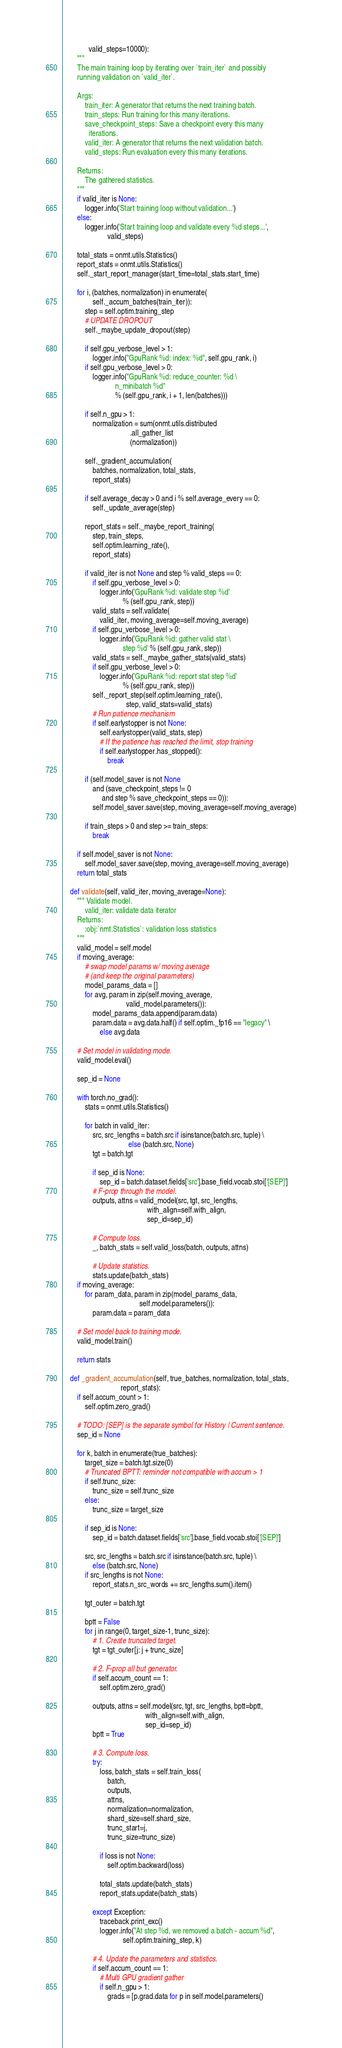<code> <loc_0><loc_0><loc_500><loc_500><_Python_>              valid_steps=10000):
        """
        The main training loop by iterating over `train_iter` and possibly
        running validation on `valid_iter`.

        Args:
            train_iter: A generator that returns the next training batch.
            train_steps: Run training for this many iterations.
            save_checkpoint_steps: Save a checkpoint every this many
              iterations.
            valid_iter: A generator that returns the next validation batch.
            valid_steps: Run evaluation every this many iterations.

        Returns:
            The gathered statistics.
        """
        if valid_iter is None:
            logger.info('Start training loop without validation...')
        else:
            logger.info('Start training loop and validate every %d steps...',
                        valid_steps)

        total_stats = onmt.utils.Statistics()
        report_stats = onmt.utils.Statistics()
        self._start_report_manager(start_time=total_stats.start_time)

        for i, (batches, normalization) in enumerate(
                self._accum_batches(train_iter)):
            step = self.optim.training_step
            # UPDATE DROPOUT
            self._maybe_update_dropout(step)

            if self.gpu_verbose_level > 1:
                logger.info("GpuRank %d: index: %d", self.gpu_rank, i)
            if self.gpu_verbose_level > 0:
                logger.info("GpuRank %d: reduce_counter: %d \
                            n_minibatch %d"
                            % (self.gpu_rank, i + 1, len(batches)))

            if self.n_gpu > 1:
                normalization = sum(onmt.utils.distributed
                                    .all_gather_list
                                    (normalization))

            self._gradient_accumulation(
                batches, normalization, total_stats,
                report_stats)

            if self.average_decay > 0 and i % self.average_every == 0:
                self._update_average(step)

            report_stats = self._maybe_report_training(
                step, train_steps,
                self.optim.learning_rate(),
                report_stats)

            if valid_iter is not None and step % valid_steps == 0:
                if self.gpu_verbose_level > 0:
                    logger.info('GpuRank %d: validate step %d'
                                % (self.gpu_rank, step))
                valid_stats = self.validate(
                    valid_iter, moving_average=self.moving_average)
                if self.gpu_verbose_level > 0:
                    logger.info('GpuRank %d: gather valid stat \
                                step %d' % (self.gpu_rank, step))
                valid_stats = self._maybe_gather_stats(valid_stats)
                if self.gpu_verbose_level > 0:
                    logger.info('GpuRank %d: report stat step %d'
                                % (self.gpu_rank, step))
                self._report_step(self.optim.learning_rate(),
                                  step, valid_stats=valid_stats)
                # Run patience mechanism
                if self.earlystopper is not None:
                    self.earlystopper(valid_stats, step)
                    # If the patience has reached the limit, stop training
                    if self.earlystopper.has_stopped():
                        break

            if (self.model_saver is not None
                and (save_checkpoint_steps != 0
                     and step % save_checkpoint_steps == 0)):
                self.model_saver.save(step, moving_average=self.moving_average)

            if train_steps > 0 and step >= train_steps:
                break

        if self.model_saver is not None:
            self.model_saver.save(step, moving_average=self.moving_average)
        return total_stats

    def validate(self, valid_iter, moving_average=None):
        """ Validate model.
            valid_iter: validate data iterator
        Returns:
            :obj:`nmt.Statistics`: validation loss statistics
        """
        valid_model = self.model
        if moving_average:
            # swap model params w/ moving average
            # (and keep the original parameters)
            model_params_data = []
            for avg, param in zip(self.moving_average,
                                  valid_model.parameters()):
                model_params_data.append(param.data)
                param.data = avg.data.half() if self.optim._fp16 == "legacy" \
                    else avg.data

        # Set model in validating mode.
        valid_model.eval()

        sep_id = None

        with torch.no_grad():
            stats = onmt.utils.Statistics()

            for batch in valid_iter:
                src, src_lengths = batch.src if isinstance(batch.src, tuple) \
                                   else (batch.src, None)
                tgt = batch.tgt

                if sep_id is None:
                    sep_id = batch.dataset.fields['src'].base_field.vocab.stoi['[SEP]']
                # F-prop through the model.
                outputs, attns = valid_model(src, tgt, src_lengths,
                                             with_align=self.with_align,
                                             sep_id=sep_id)

                # Compute loss.
                _, batch_stats = self.valid_loss(batch, outputs, attns)

                # Update statistics.
                stats.update(batch_stats)
        if moving_average:
            for param_data, param in zip(model_params_data,
                                         self.model.parameters()):
                param.data = param_data

        # Set model back to training mode.
        valid_model.train()

        return stats

    def _gradient_accumulation(self, true_batches, normalization, total_stats,
                               report_stats):
        if self.accum_count > 1:
            self.optim.zero_grad()

        # TODO: [SEP] is the separate symbol for History | Current sentence.
        sep_id = None

        for k, batch in enumerate(true_batches):
            target_size = batch.tgt.size(0)
            # Truncated BPTT: reminder not compatible with accum > 1
            if self.trunc_size:
                trunc_size = self.trunc_size
            else:
                trunc_size = target_size

            if sep_id is None:
                sep_id = batch.dataset.fields['src'].base_field.vocab.stoi['[SEP]']

            src, src_lengths = batch.src if isinstance(batch.src, tuple) \
                else (batch.src, None)
            if src_lengths is not None:
                report_stats.n_src_words += src_lengths.sum().item()

            tgt_outer = batch.tgt

            bptt = False
            for j in range(0, target_size-1, trunc_size):
                # 1. Create truncated target.
                tgt = tgt_outer[j: j + trunc_size]

                # 2. F-prop all but generator.
                if self.accum_count == 1:
                    self.optim.zero_grad()

                outputs, attns = self.model(src, tgt, src_lengths, bptt=bptt,
                                            with_align=self.with_align,
                                            sep_id=sep_id)
                bptt = True

                # 3. Compute loss.
                try:
                    loss, batch_stats = self.train_loss(
                        batch,
                        outputs,
                        attns,
                        normalization=normalization,
                        shard_size=self.shard_size,
                        trunc_start=j,
                        trunc_size=trunc_size)

                    if loss is not None:
                        self.optim.backward(loss)

                    total_stats.update(batch_stats)
                    report_stats.update(batch_stats)

                except Exception:
                    traceback.print_exc()
                    logger.info("At step %d, we removed a batch - accum %d",
                                self.optim.training_step, k)

                # 4. Update the parameters and statistics.
                if self.accum_count == 1:
                    # Multi GPU gradient gather
                    if self.n_gpu > 1:
                        grads = [p.grad.data for p in self.model.parameters()</code> 